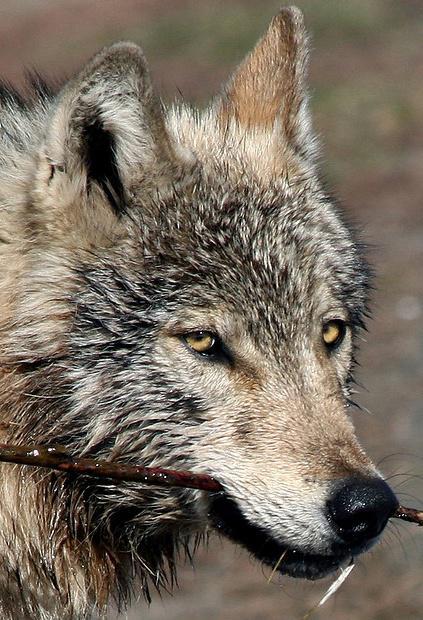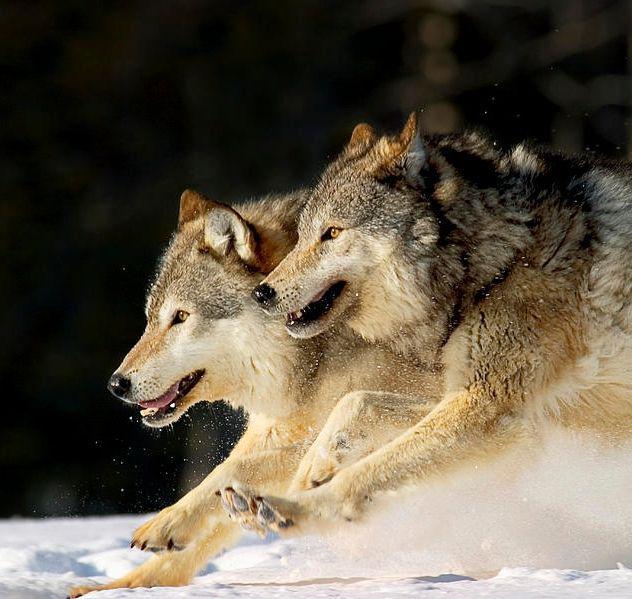The first image is the image on the left, the second image is the image on the right. For the images displayed, is the sentence "The combined images include two wolves in running poses." factually correct? Answer yes or no. Yes. 